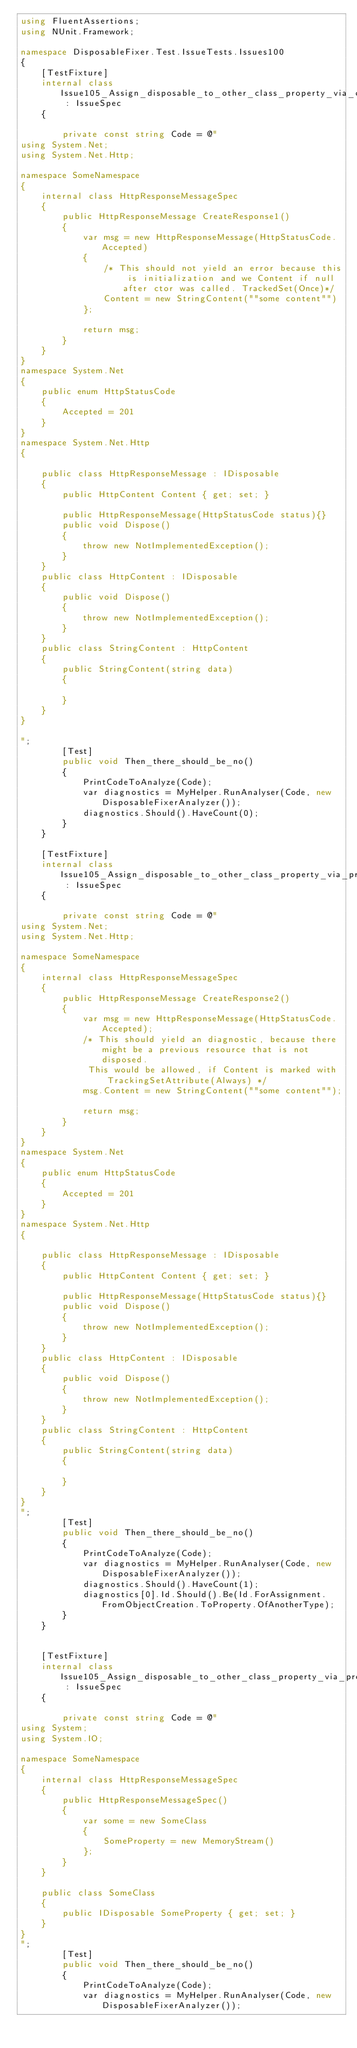Convert code to text. <code><loc_0><loc_0><loc_500><loc_500><_C#_>using FluentAssertions;
using NUnit.Framework;

namespace DisposableFixer.Test.IssueTests.Issues100
{
    [TestFixture]
    internal class Issue105_Assign_disposable_to_other_class_property_via_object_initialization : IssueSpec
    {

        private const string Code = @"
using System.Net;
using System.Net.Http;

namespace SomeNamespace
{
    internal class HttpResponseMessageSpec
    {
        public HttpResponseMessage CreateResponse1()
        {
            var msg = new HttpResponseMessage(HttpStatusCode.Accepted)
            {
                /* This should not yield an error because this is initialization and we Content if null after ctor was called. TrackedSet(Once)*/
                Content = new StringContent(""some content"")
            };
            
            return msg;
        }
    }
}
namespace System.Net
{
    public enum HttpStatusCode
    {
        Accepted = 201
    }
}
namespace System.Net.Http
{
    
    public class HttpResponseMessage : IDisposable
    {
        public HttpContent Content { get; set; }

        public HttpResponseMessage(HttpStatusCode status){}
        public void Dispose()
        {
            throw new NotImplementedException();
        }
    }
    public class HttpContent : IDisposable
    {
        public void Dispose()
        {
            throw new NotImplementedException();
        }
    }
    public class StringContent : HttpContent
    {
        public StringContent(string data)
        {

        }
    }
}

";
        [Test]
        public void Then_there_should_be_no()
        {
            PrintCodeToAnalyze(Code);
            var diagnostics = MyHelper.RunAnalyser(Code, new DisposableFixerAnalyzer());
            diagnostics.Should().HaveCount(0);
        }
    }

    [TestFixture]
    internal class Issue105_Assign_disposable_to_other_class_property_via_property_setter : IssueSpec
    {

        private const string Code = @"
using System.Net;
using System.Net.Http;

namespace SomeNamespace
{
    internal class HttpResponseMessageSpec
    {
        public HttpResponseMessage CreateResponse2()
        {
            var msg = new HttpResponseMessage(HttpStatusCode.Accepted);
            /* This should yield an diagnostic, because there might be a previous resource that is not disposed.
             This would be allowed, if Content is marked with TrackingSetAttribute(Always) */
            msg.Content = new StringContent(""some content"");

            return msg;
        }
    }
}
namespace System.Net
{
    public enum HttpStatusCode
    {
        Accepted = 201
    }
}
namespace System.Net.Http
{
    
    public class HttpResponseMessage : IDisposable
    {
        public HttpContent Content { get; set; }

        public HttpResponseMessage(HttpStatusCode status){}
        public void Dispose()
        {
            throw new NotImplementedException();
        }
    }
    public class HttpContent : IDisposable
    {
        public void Dispose()
        {
            throw new NotImplementedException();
        }
    }
    public class StringContent : HttpContent
    {
        public StringContent(string data)
        {

        }
    }
}
";
        [Test]
        public void Then_there_should_be_no()
        {
            PrintCodeToAnalyze(Code);
            var diagnostics = MyHelper.RunAnalyser(Code, new DisposableFixerAnalyzer());
            diagnostics.Should().HaveCount(1);
            diagnostics[0].Id.Should().Be(Id.ForAssignment.FromObjectCreation.ToProperty.OfAnotherType);
        }
    }


    [TestFixture]
    internal class Issue105_Assign_disposable_to_other_class_property_via_property_setter_that_is_not_tracked_set : IssueSpec
    {

        private const string Code = @"
using System;
using System.IO;

namespace SomeNamespace
{
    internal class HttpResponseMessageSpec
    {
        public HttpResponseMessageSpec()
        {
            var some = new SomeClass
            {
                SomeProperty = new MemoryStream()
            };
        }
    }

    public class SomeClass
    {
        public IDisposable SomeProperty { get; set; }
    }
}
";
        [Test]
        public void Then_there_should_be_no()
        {
            PrintCodeToAnalyze(Code);
            var diagnostics = MyHelper.RunAnalyser(Code, new DisposableFixerAnalyzer());</code> 